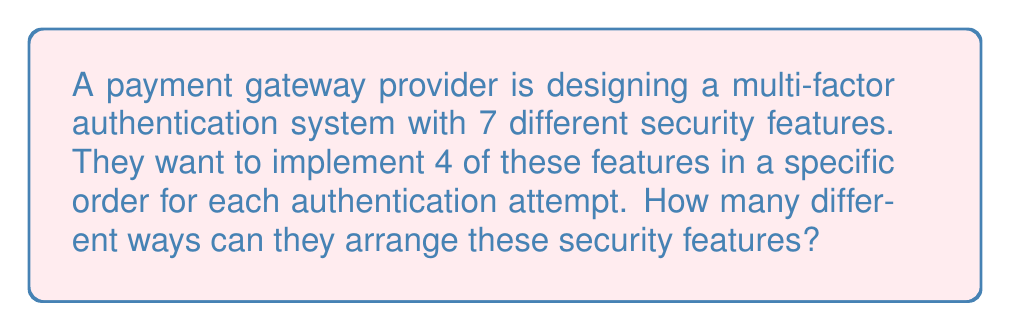Show me your answer to this math problem. To solve this problem, we need to use the concept of permutations. Here's a step-by-step explanation:

1. We have 7 total security features to choose from, and we need to select and arrange 4 of them.

2. This is a permutation problem because the order matters (we're arranging the features in a specific order).

3. We use the permutation formula:
   
   $$P(n,r) = \frac{n!}{(n-r)!}$$

   Where:
   $n$ = total number of items to choose from (7 security features)
   $r$ = number of items being chosen (4 features to implement)

4. Plugging in our values:

   $$P(7,4) = \frac{7!}{(7-4)!} = \frac{7!}{3!}$$

5. Expand this:
   
   $$\frac{7 \times 6 \times 5 \times 4 \times 3!}{3!}$$

6. The $3!$ cancels out in the numerator and denominator:

   $$7 \times 6 \times 5 \times 4 = 840$$

Therefore, there are 840 different ways to arrange 4 security features out of 7 in a specific order.
Answer: 840 